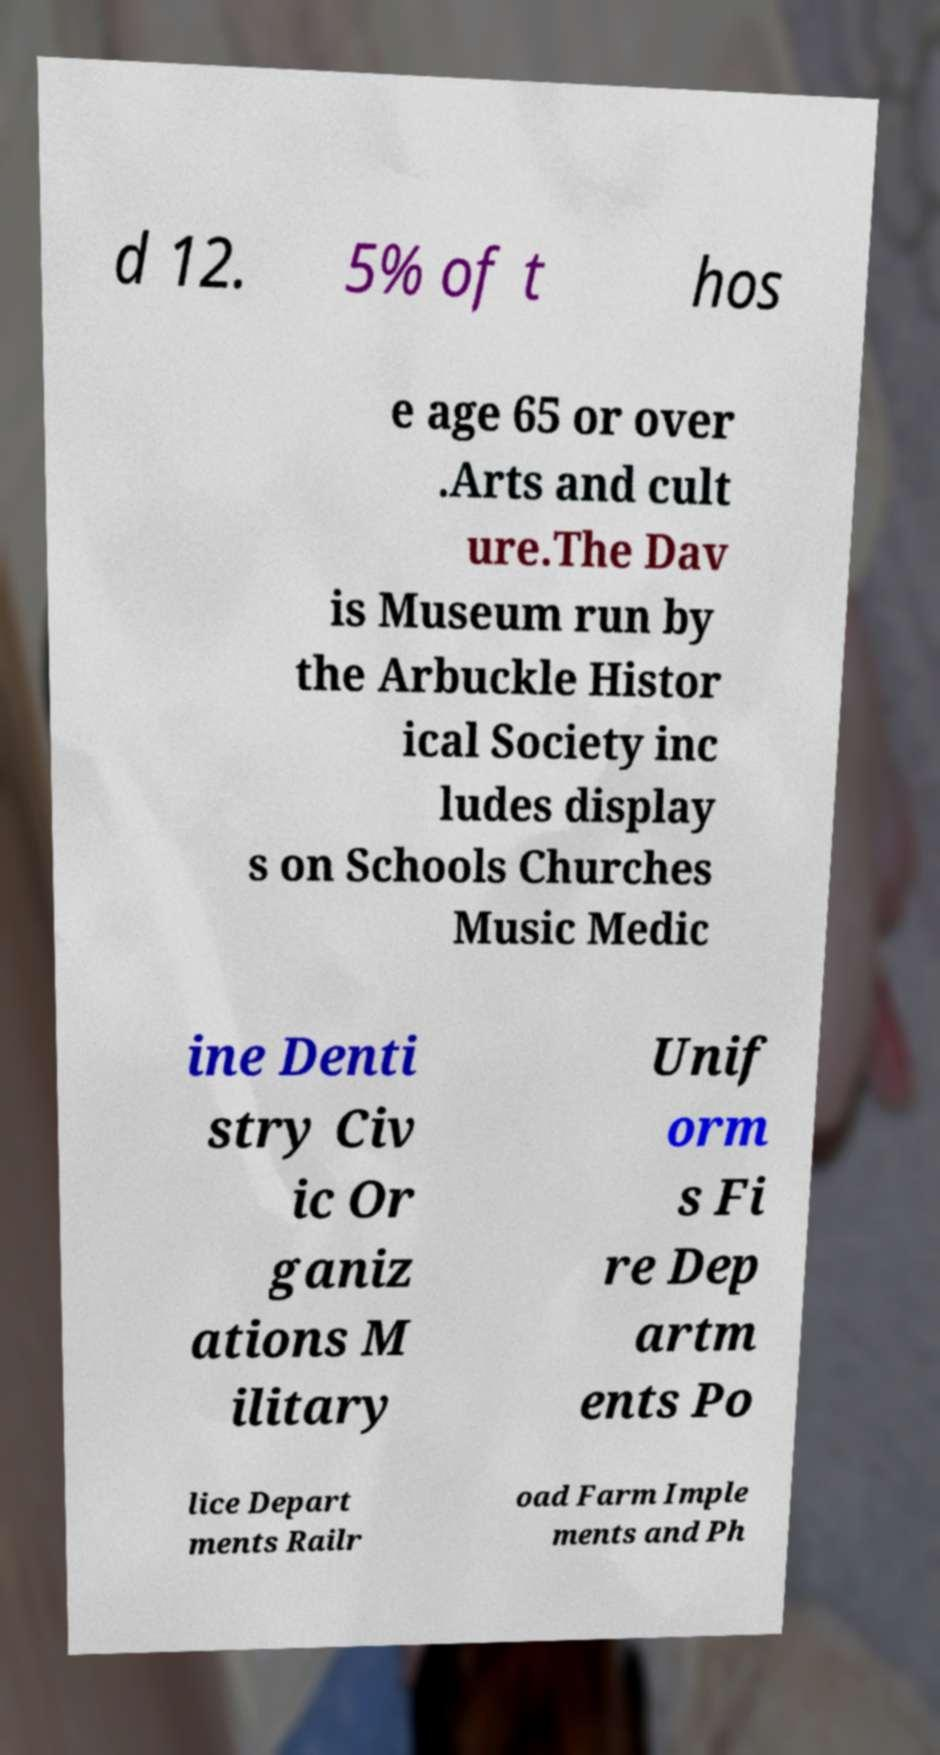Can you read and provide the text displayed in the image?This photo seems to have some interesting text. Can you extract and type it out for me? d 12. 5% of t hos e age 65 or over .Arts and cult ure.The Dav is Museum run by the Arbuckle Histor ical Society inc ludes display s on Schools Churches Music Medic ine Denti stry Civ ic Or ganiz ations M ilitary Unif orm s Fi re Dep artm ents Po lice Depart ments Railr oad Farm Imple ments and Ph 